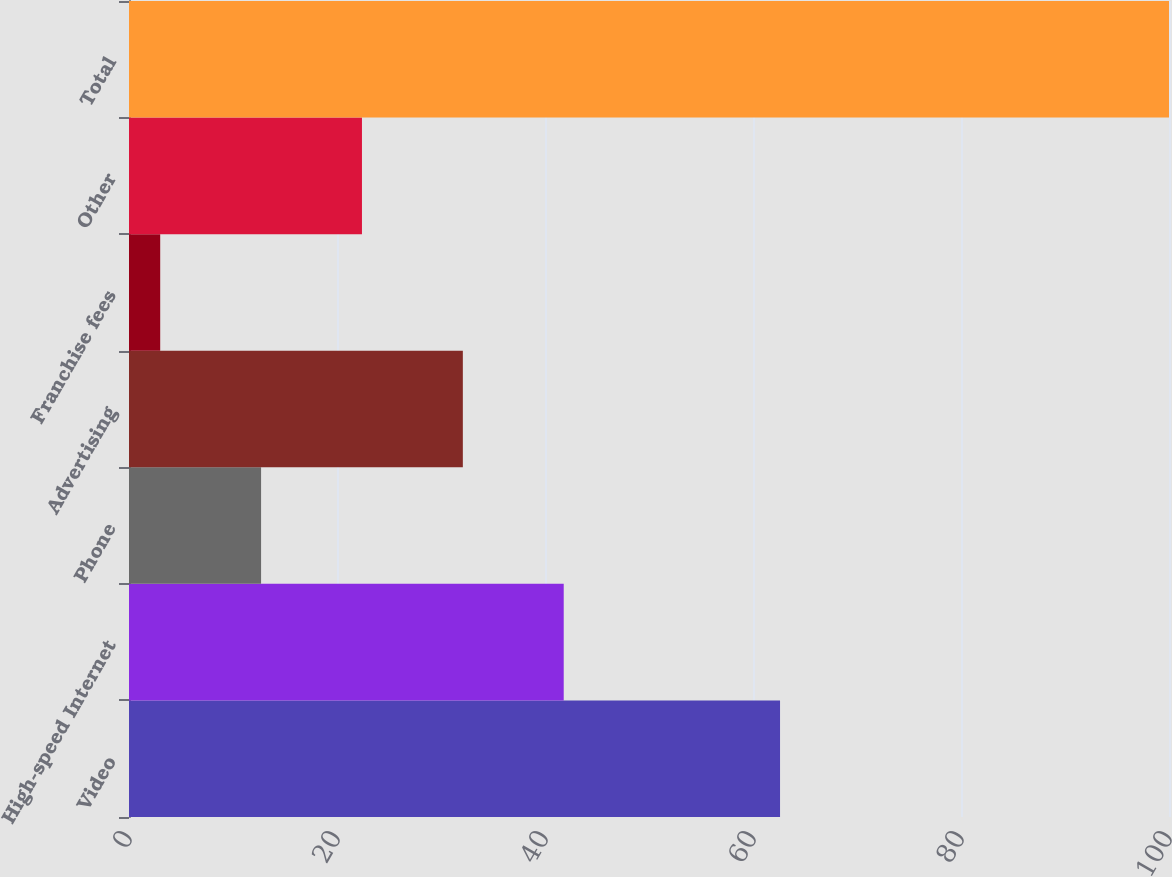Convert chart. <chart><loc_0><loc_0><loc_500><loc_500><bar_chart><fcel>Video<fcel>High-speed Internet<fcel>Phone<fcel>Advertising<fcel>Franchise fees<fcel>Other<fcel>Total<nl><fcel>62.6<fcel>41.8<fcel>12.7<fcel>32.1<fcel>3<fcel>22.4<fcel>100<nl></chart> 